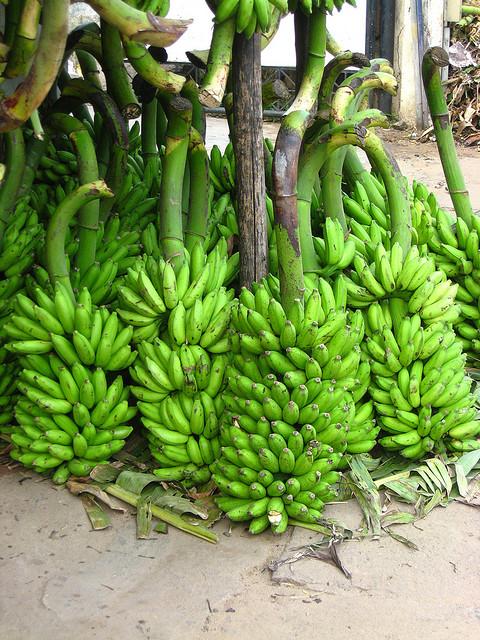Is this plant edible?
Answer briefly. Yes. Are bananas arranged to sell?
Answer briefly. No. What is this a picture of?
Write a very short answer. Bananas. Is this fruit ripe?
Short answer required. No. Are the bananas ready to it?
Give a very brief answer. No. 